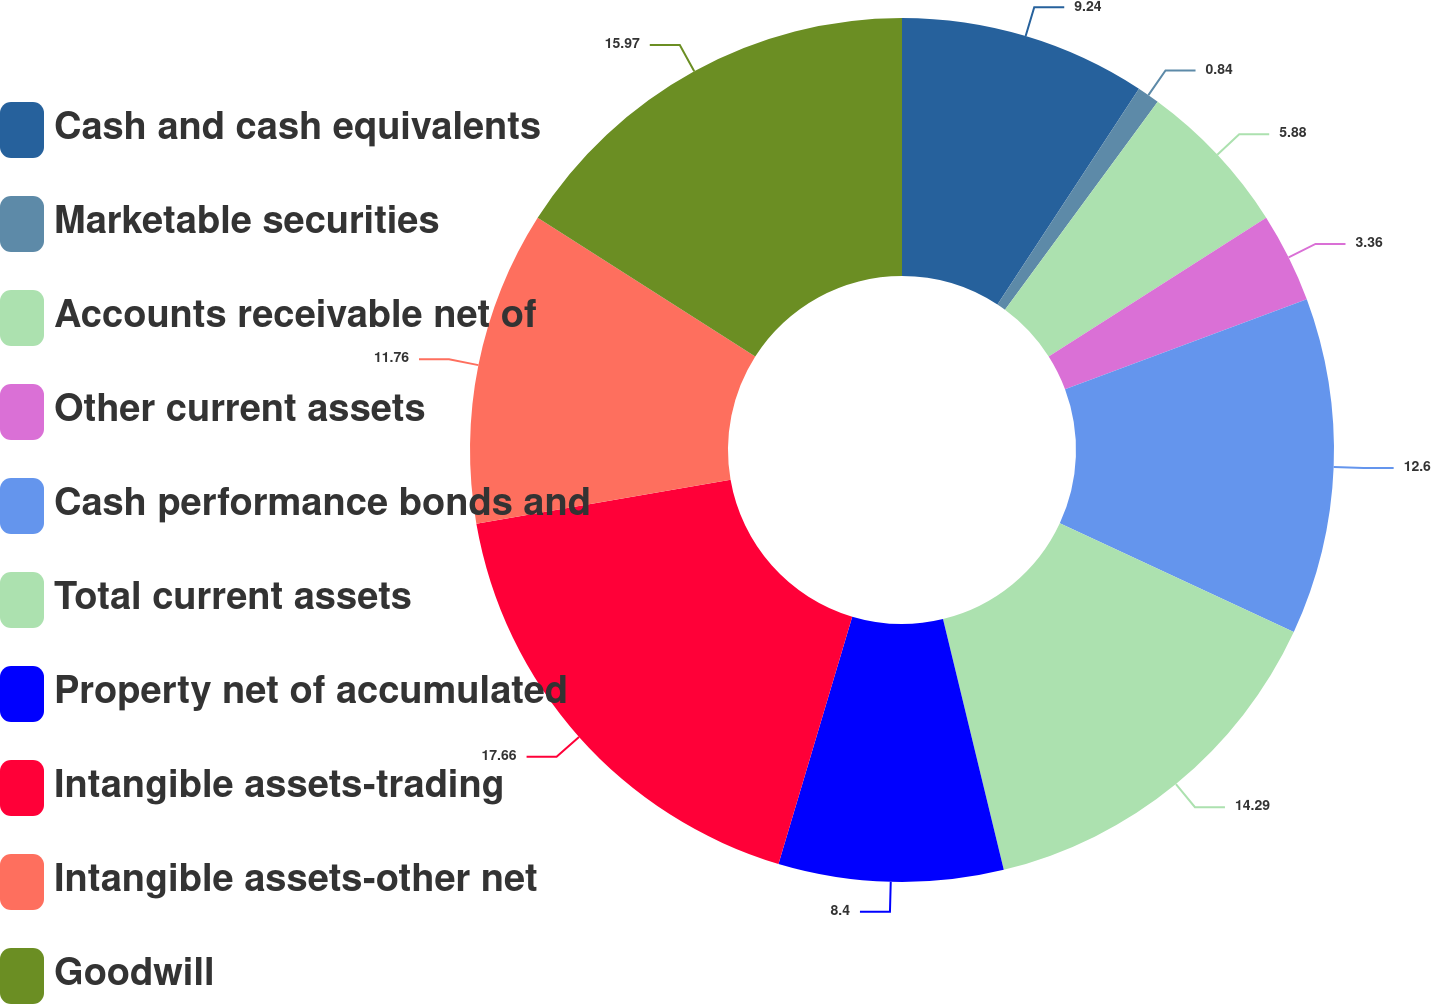Convert chart. <chart><loc_0><loc_0><loc_500><loc_500><pie_chart><fcel>Cash and cash equivalents<fcel>Marketable securities<fcel>Accounts receivable net of<fcel>Other current assets<fcel>Cash performance bonds and<fcel>Total current assets<fcel>Property net of accumulated<fcel>Intangible assets-trading<fcel>Intangible assets-other net<fcel>Goodwill<nl><fcel>9.24%<fcel>0.84%<fcel>5.88%<fcel>3.36%<fcel>12.6%<fcel>14.29%<fcel>8.4%<fcel>17.65%<fcel>11.76%<fcel>15.97%<nl></chart> 